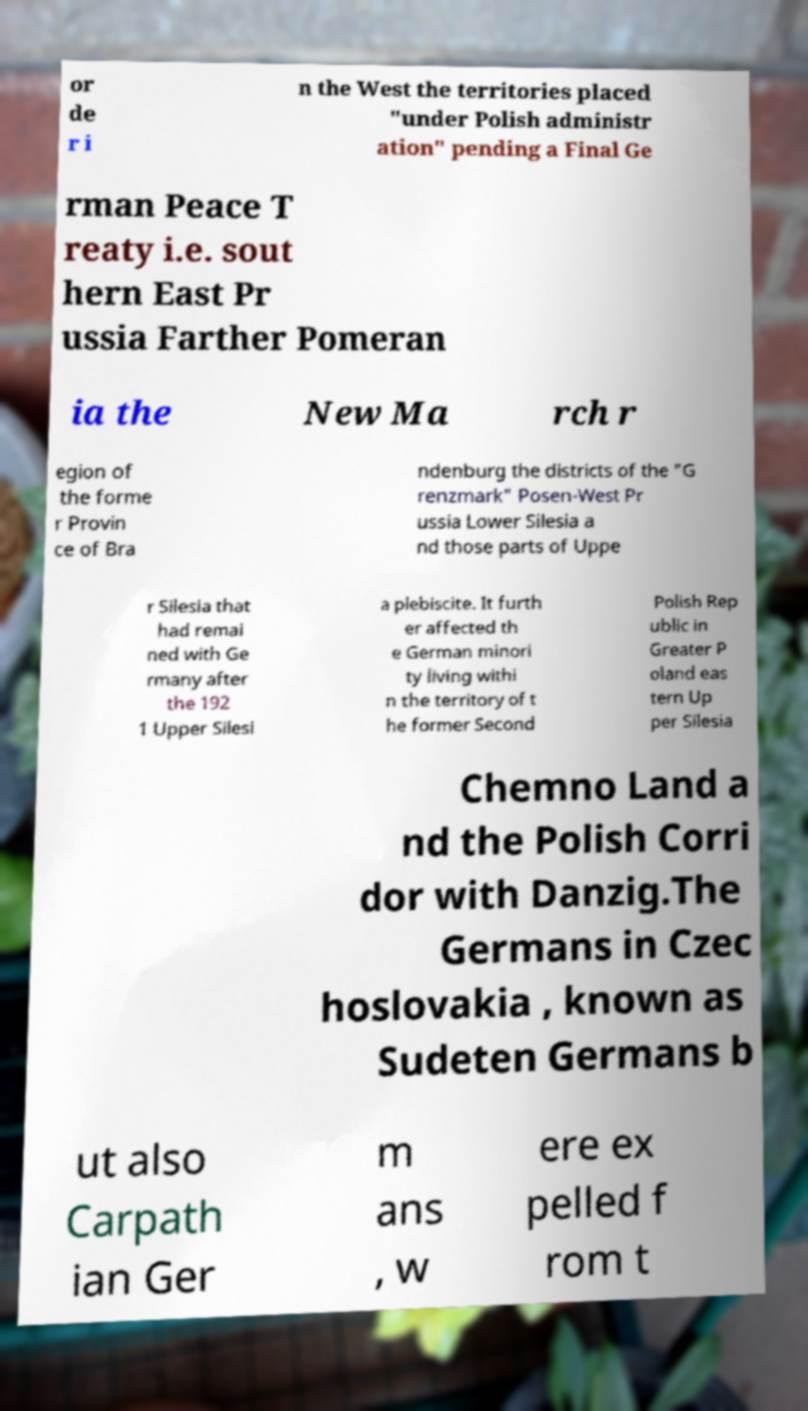Please read and relay the text visible in this image. What does it say? or de r i n the West the territories placed "under Polish administr ation" pending a Final Ge rman Peace T reaty i.e. sout hern East Pr ussia Farther Pomeran ia the New Ma rch r egion of the forme r Provin ce of Bra ndenburg the districts of the "G renzmark" Posen-West Pr ussia Lower Silesia a nd those parts of Uppe r Silesia that had remai ned with Ge rmany after the 192 1 Upper Silesi a plebiscite. It furth er affected th e German minori ty living withi n the territory of t he former Second Polish Rep ublic in Greater P oland eas tern Up per Silesia Chemno Land a nd the Polish Corri dor with Danzig.The Germans in Czec hoslovakia , known as Sudeten Germans b ut also Carpath ian Ger m ans , w ere ex pelled f rom t 